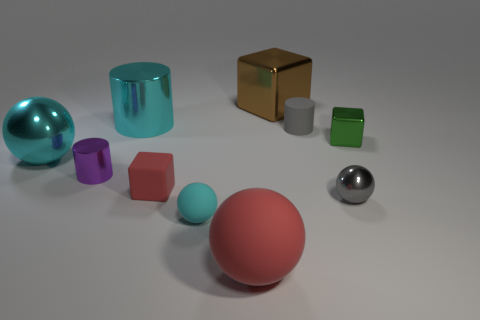Subtract all yellow blocks. How many cyan spheres are left? 2 Subtract 2 spheres. How many spheres are left? 2 Subtract all red balls. How many balls are left? 3 Subtract all tiny cyan balls. How many balls are left? 3 Subtract all brown cylinders. Subtract all cyan cubes. How many cylinders are left? 3 Subtract all cylinders. How many objects are left? 7 Add 10 green metal cylinders. How many green metal cylinders exist? 10 Subtract 1 red cubes. How many objects are left? 9 Subtract all tiny cylinders. Subtract all tiny red matte things. How many objects are left? 7 Add 3 small cyan things. How many small cyan things are left? 4 